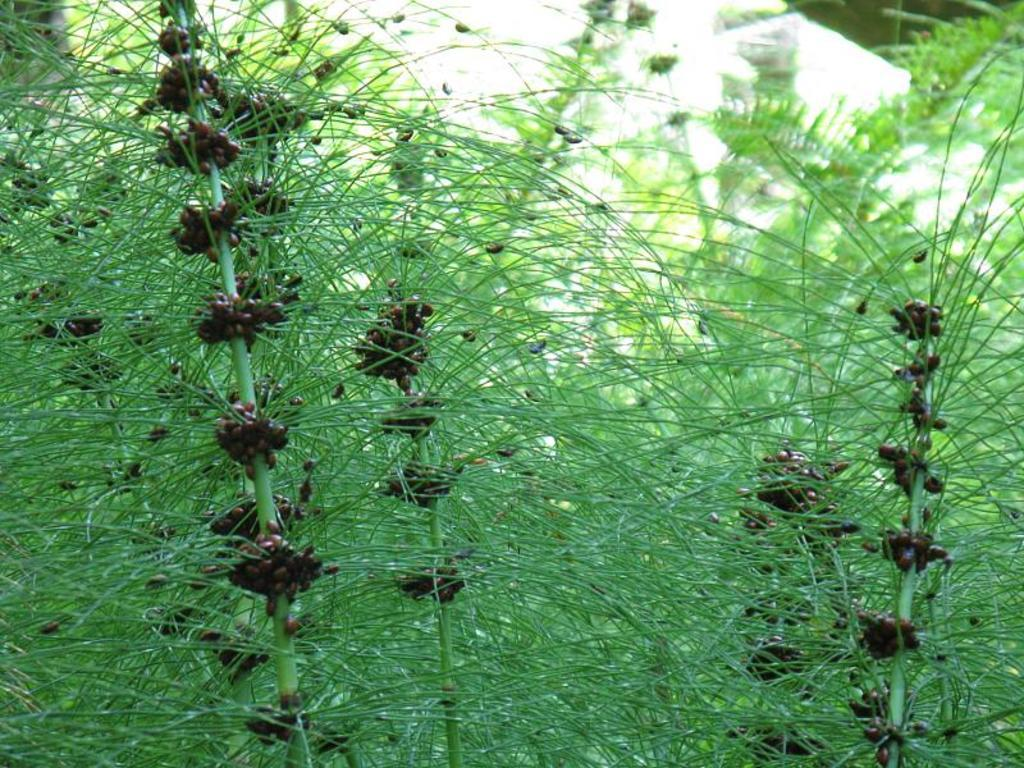What type of plants can be seen in the image? There are plants with seeds in the image. Can you describe the background of the image? The background of the image is blurred. What type of record can be seen playing in the background of the image? There is no record or any indication of music playing in the image; it only features plants with seeds and a blurred background. 